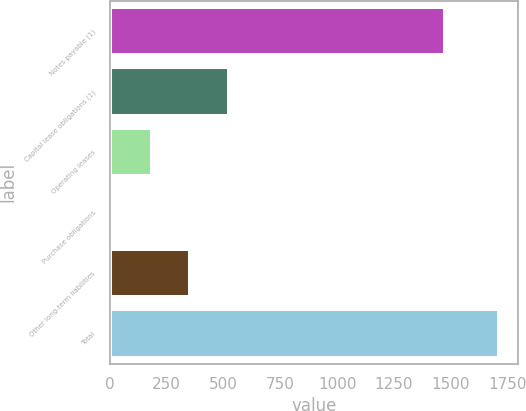Convert chart. <chart><loc_0><loc_0><loc_500><loc_500><bar_chart><fcel>Notes payable (1)<fcel>Capital lease obligations (1)<fcel>Operating leases<fcel>Purchase obligations<fcel>Other long-term liabilities<fcel>Total<nl><fcel>1473<fcel>522.7<fcel>182.9<fcel>13<fcel>352.8<fcel>1712<nl></chart> 